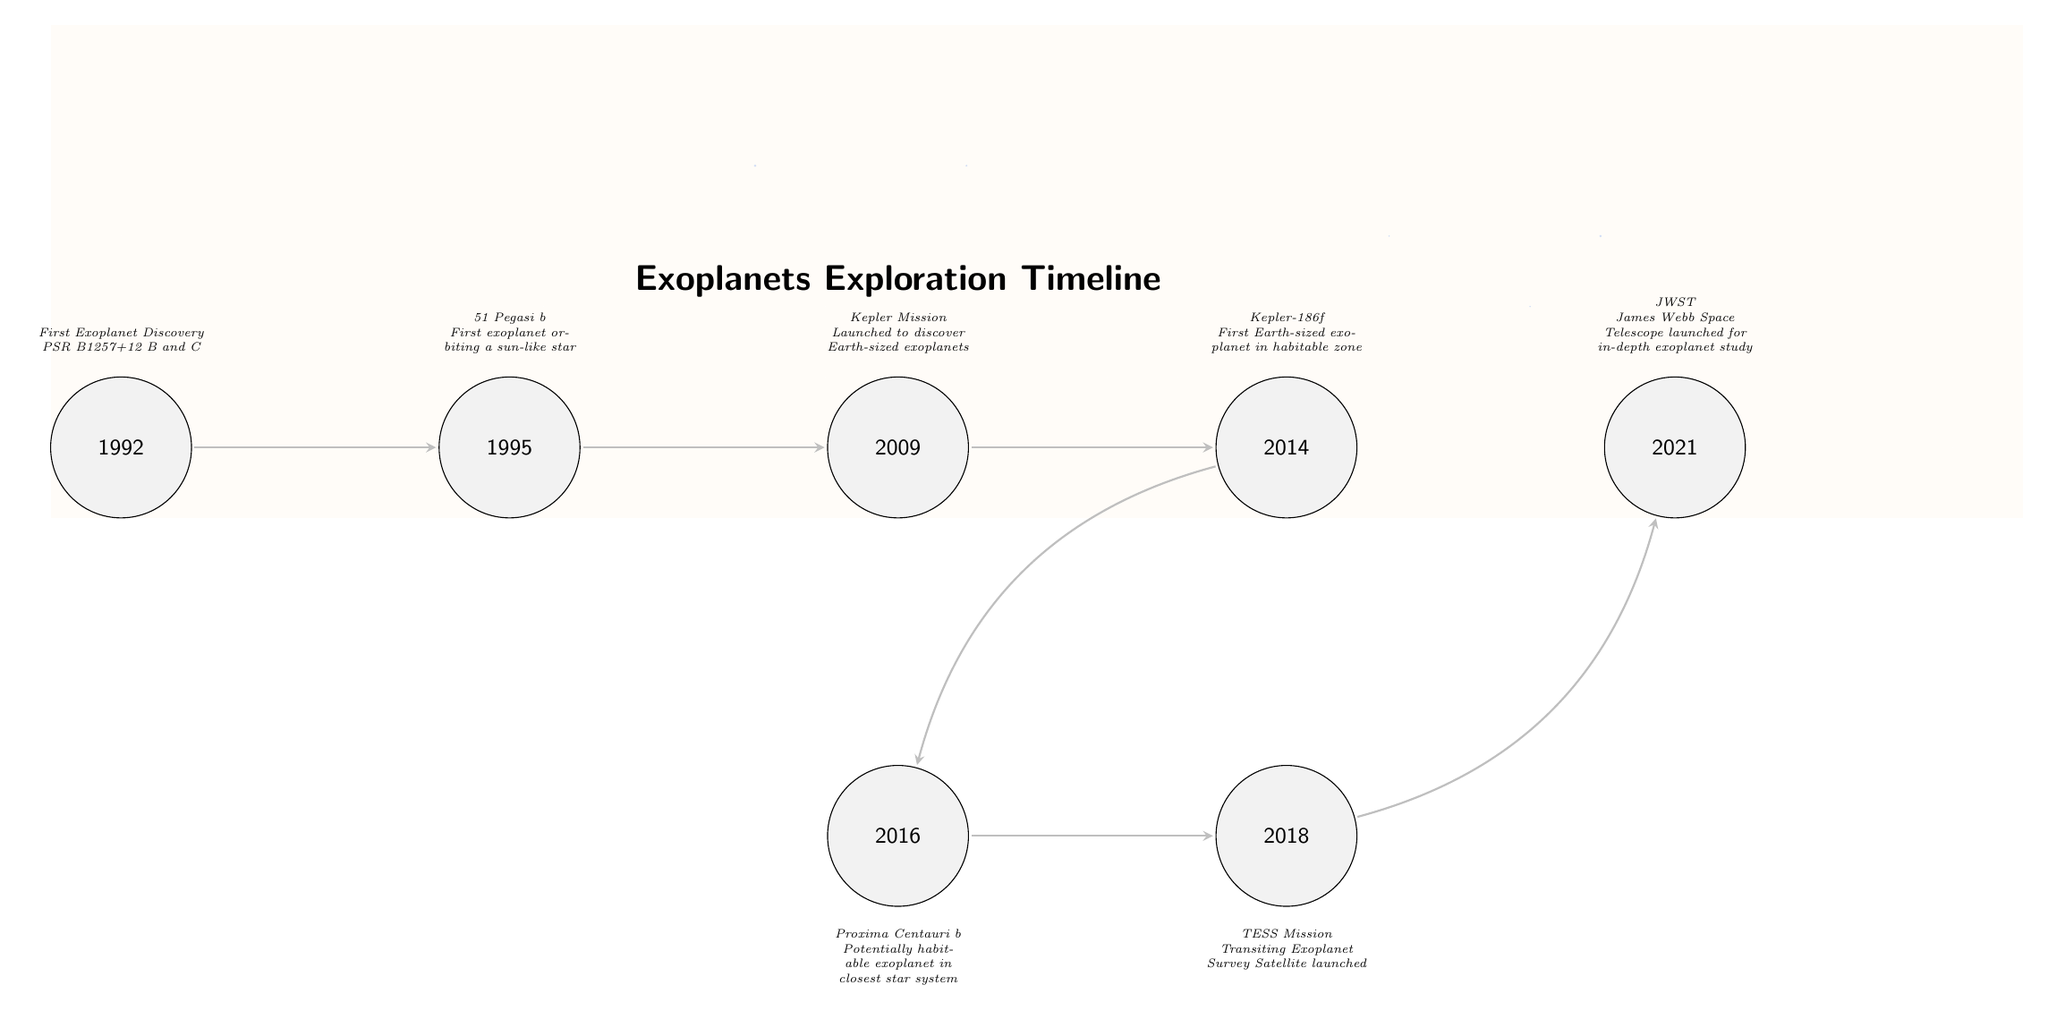What year was the first exoplanet discovered? The diagram indicates that the first exoplanet was discovered in 1992, as marked on the timeline node labeled "1992."
Answer: 1992 What is the name of the first exoplanet discovered around a sun-like star? The diagram includes a node for 1995, with the description stating "51 Pegasi b," which identifies it as the first exoplanet orbiting a sun-like star.
Answer: 51 Pegasi b How many events are shown on the timeline? Counting the nodes on the diagram — from 1992 to 2021 — there are a total of 7 events represented.
Answer: 7 What mission was launched in 2009? The node for 2009 indicates that the "Kepler Mission" was launched during that year with the purpose of discovering Earth-sized exoplanets.
Answer: Kepler Mission Which exoplanet was discovered in 2014? According to the diagram, the event in 2014 describes "Kepler-186f," indicating it was the first Earth-sized exoplanet found in the habitable zone.
Answer: Kepler-186f What notable telescope was launched in 2021? The node for 2021 mentions that the "James Webb Space Telescope" (JWST) was launched for an in-depth study of exoplanets.
Answer: James Webb Space Telescope Which exoplanet discovered in 2016 is considered potentially habitable? The diagram's description for the 2016 event refers to "Proxima Centauri b," indicating that it is a potentially habitable exoplanet.
Answer: Proxima Centauri b How does the timeline ultimately progress from 2014 and which event follows it? The diagram shows that after 2014 (Kepler-186f), the timeline bends right to link to the 2016 event (Proxima Centauri b), indicating that it follows in years.
Answer: Proxima Centauri b What purpose does the TESS mission launched in 2018 serve? The event in 2018 specifies that the TESS Mission, or Transiting Exoplanet Survey Satellite, was launched to survey exoplanets, which informs us of its discovery mission.
Answer: Survey exoplanets 